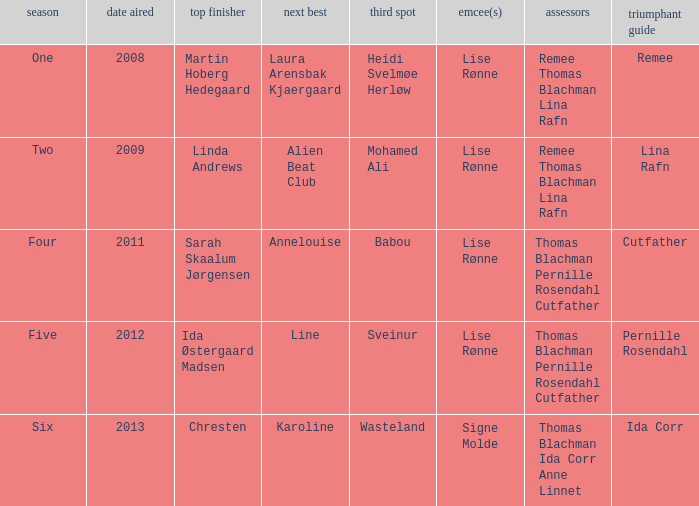Which season did Ida Corr win? Six. 